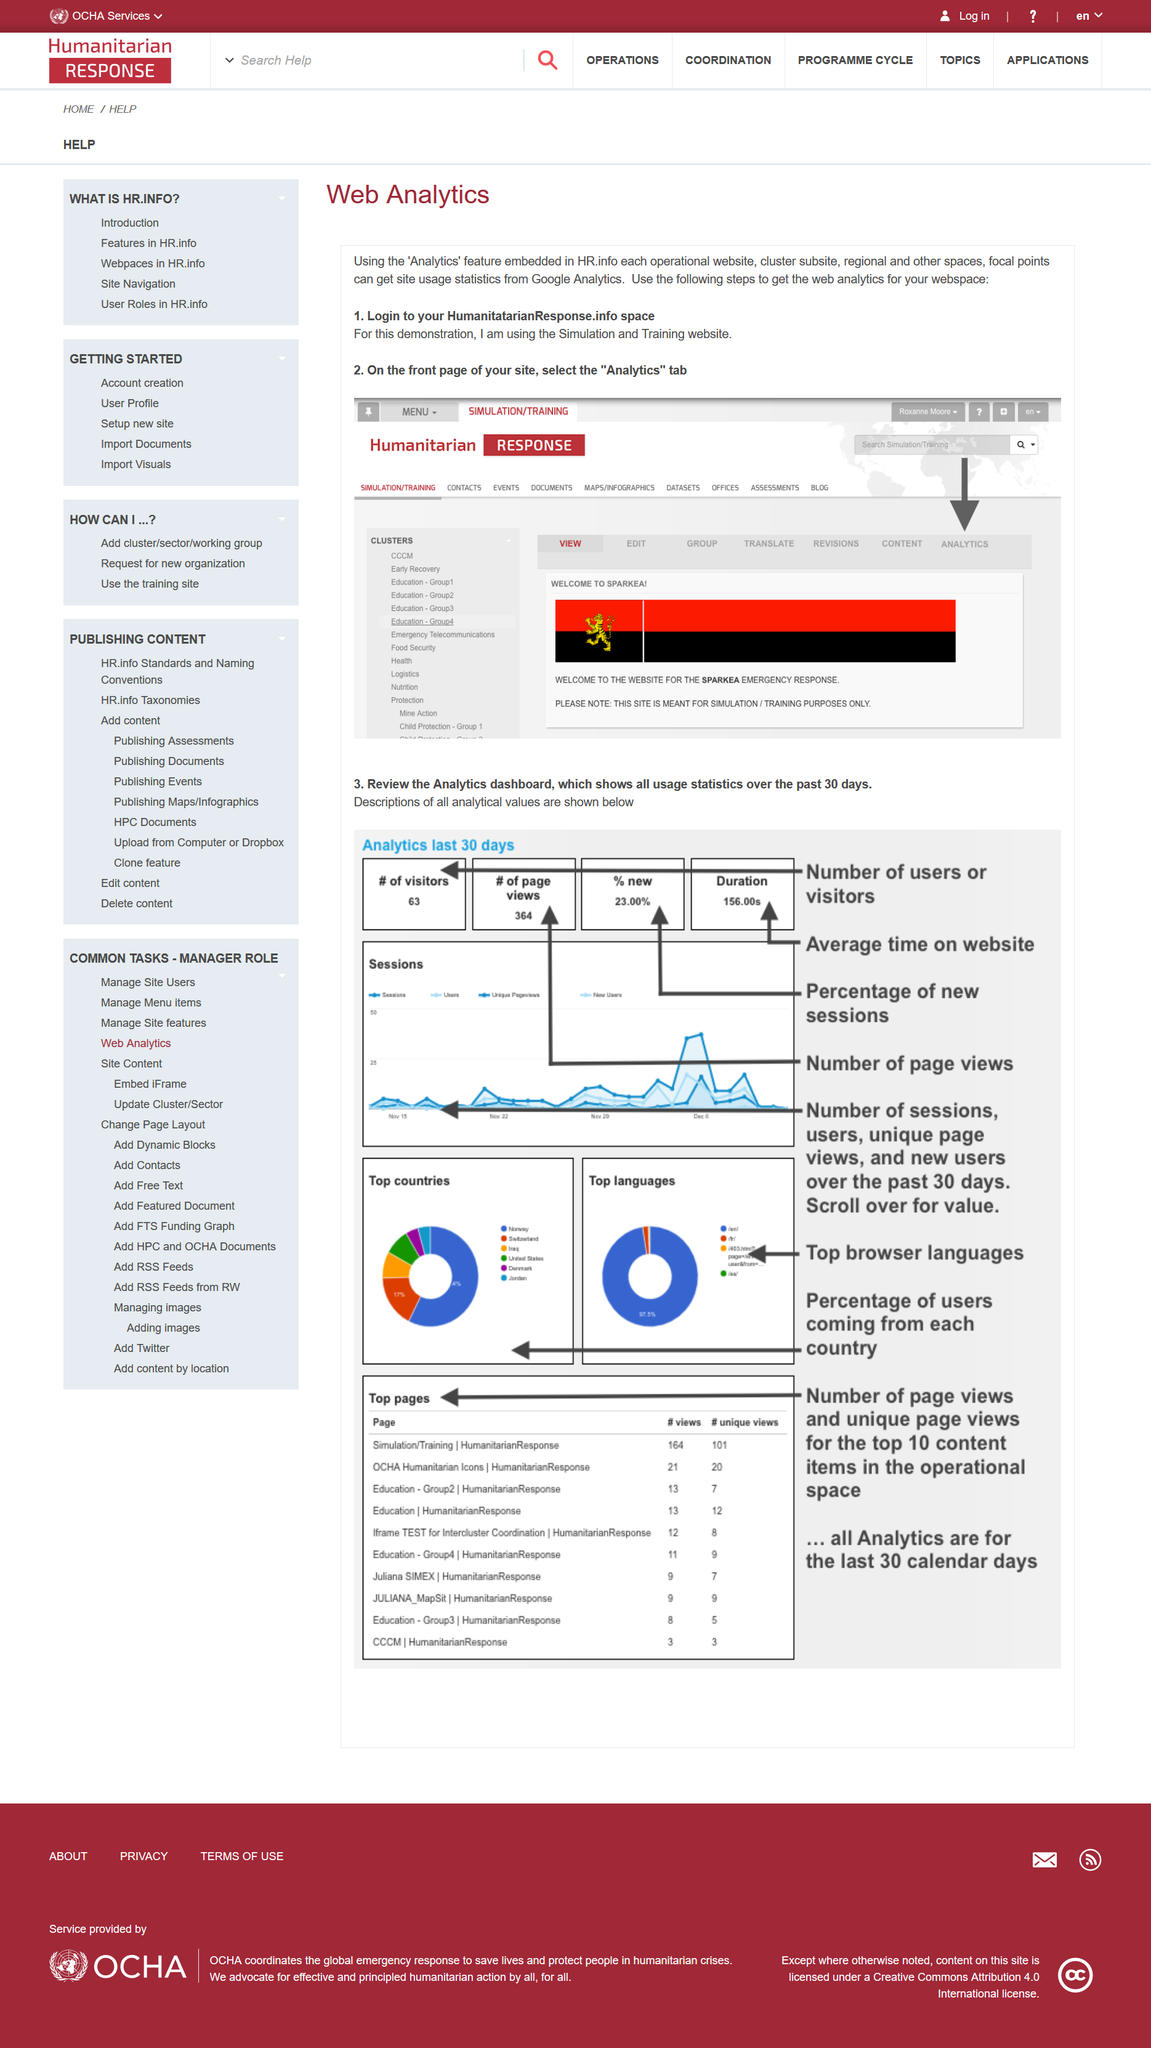List a handful of essential elements in this visual. The page is dedicated to the field of web analytics. The usage statistics can be viewed for a period of 30 days. It is necessary to log in to your HumanitarianResponse.info account in order to access the appropriate platform. 